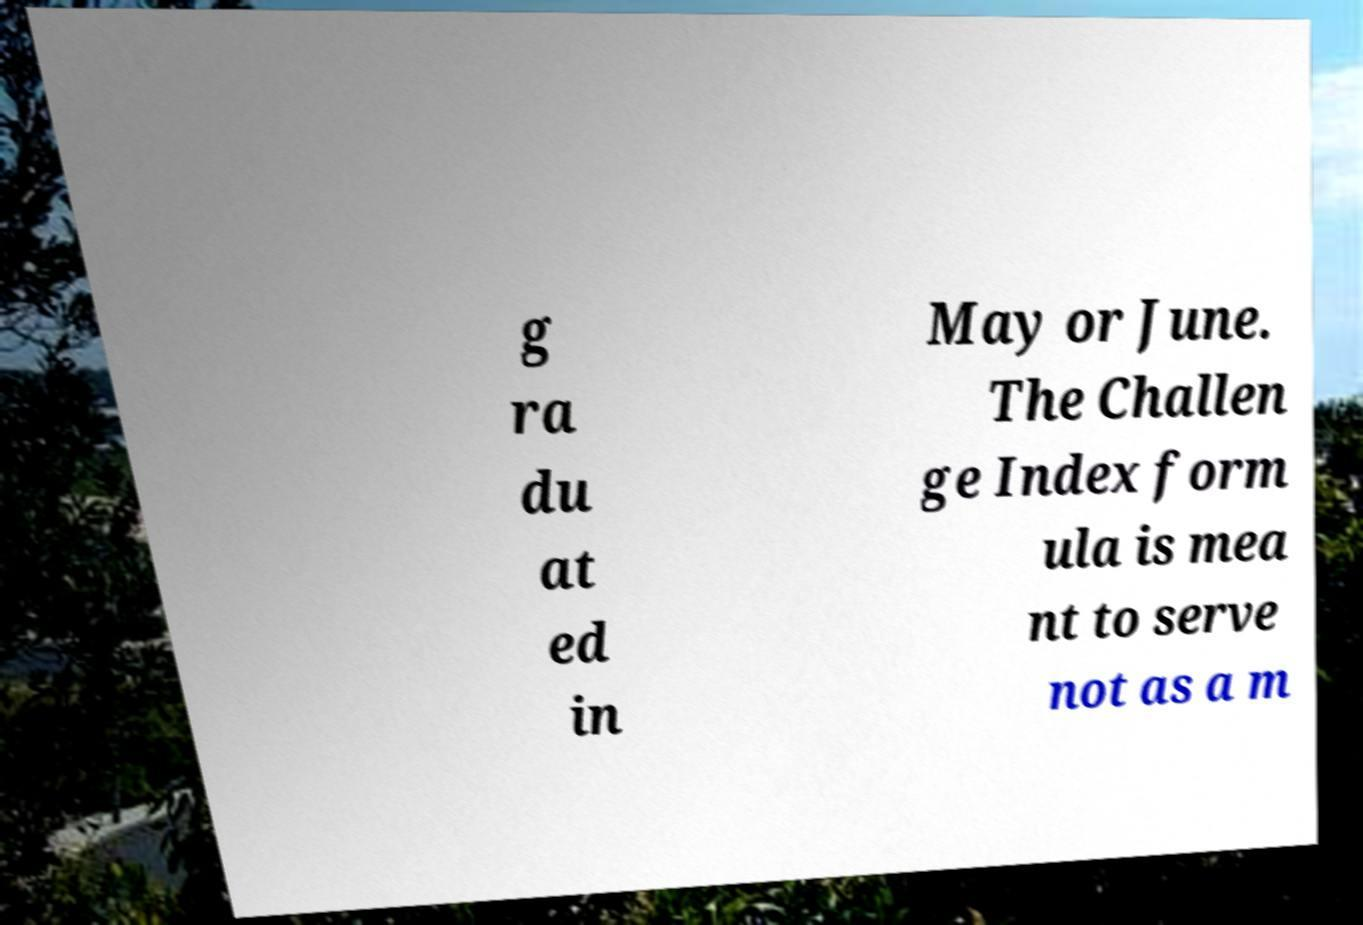Could you extract and type out the text from this image? g ra du at ed in May or June. The Challen ge Index form ula is mea nt to serve not as a m 